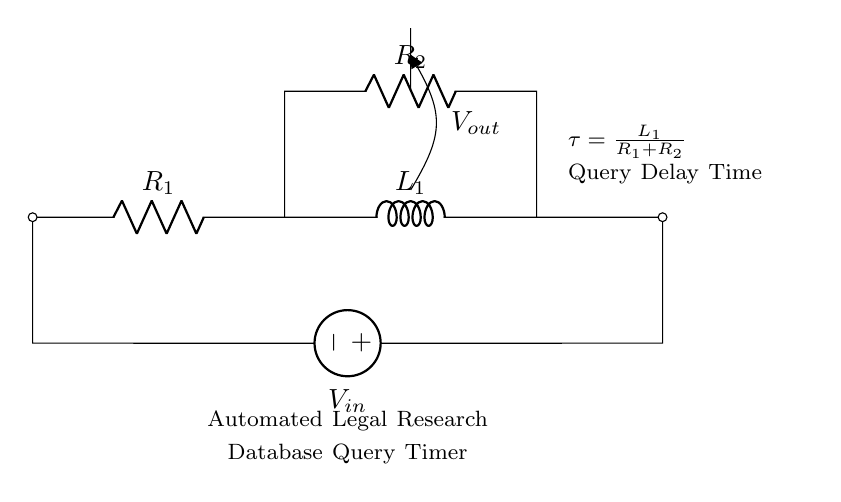What is the input voltage of the circuit? The input voltage is indicated by the voltage source labeled V_in. This value is the potential difference applied to the circuit.
Answer: V_in What are the values of the resistors in this circuit? The resistors are labeled R_1 and R_2. The specific values are not provided in the diagram but can be represented symbolically as R_1 and R_2.
Answer: R_1, R_2 What is the role of the inductor in this circuit? The inductor L_1 in the circuit stores energy in a magnetic field when current flows through it. Its presence affects the timing characteristics of the circuit.
Answer: Energy storage What is the time constant of this RC circuit? The time constant tau is calculated as the ratio of the inductance L_1 to the sum of the resistances R_1 and R_2, represented as tau = L_1 / (R_1 + R_2). This defines how quickly the circuit responds to changes in voltage.
Answer: L_1 / (R_1 + R_2) How does the output voltage relate to the components? The output voltage V_out is the voltage across a designated point in the circuit. It is affected by the voltage drop across R_2 and the time constant tau, making it dependent on R_2 and L_1.
Answer: Dependent on R_2 and L_1 What type of circuit is represented here? The circuit is a resistor-inductor circuit, which is specifically designed to manage the timing of automated legal research database queries, reflecting its application.
Answer: Resistor-inductor circuit 